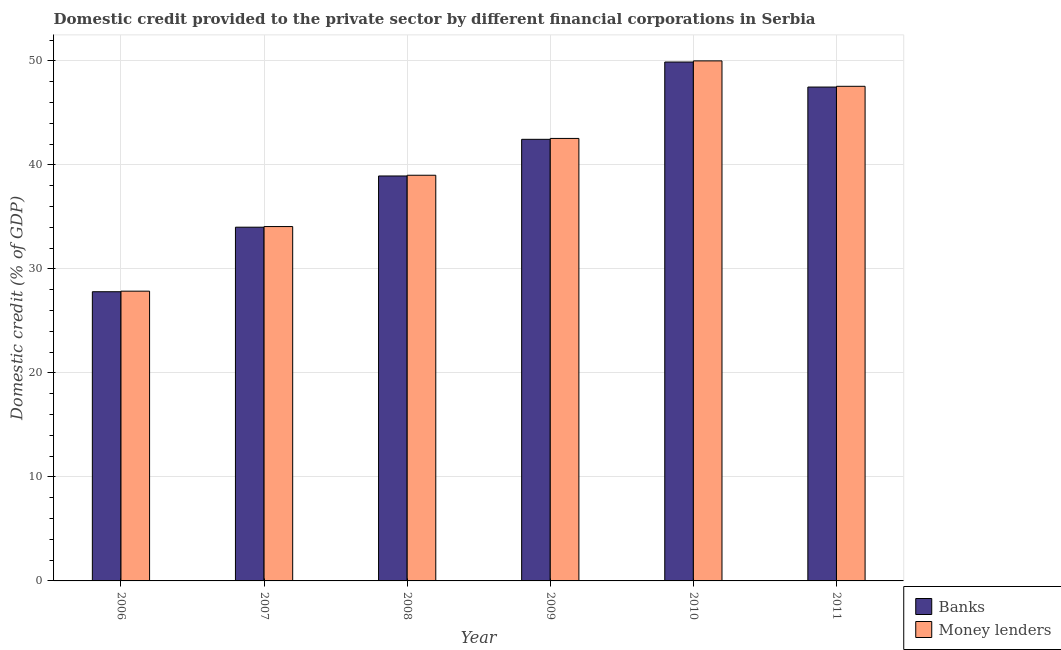How many different coloured bars are there?
Your answer should be very brief. 2. How many bars are there on the 3rd tick from the left?
Offer a very short reply. 2. How many bars are there on the 5th tick from the right?
Your answer should be compact. 2. What is the label of the 3rd group of bars from the left?
Make the answer very short. 2008. In how many cases, is the number of bars for a given year not equal to the number of legend labels?
Give a very brief answer. 0. What is the domestic credit provided by banks in 2007?
Offer a very short reply. 34.01. Across all years, what is the maximum domestic credit provided by banks?
Provide a succinct answer. 49.9. Across all years, what is the minimum domestic credit provided by banks?
Your answer should be compact. 27.81. In which year was the domestic credit provided by money lenders maximum?
Provide a short and direct response. 2010. In which year was the domestic credit provided by banks minimum?
Provide a succinct answer. 2006. What is the total domestic credit provided by money lenders in the graph?
Give a very brief answer. 241.07. What is the difference between the domestic credit provided by money lenders in 2006 and that in 2009?
Your answer should be compact. -14.69. What is the difference between the domestic credit provided by banks in 2008 and the domestic credit provided by money lenders in 2010?
Your answer should be compact. -10.96. What is the average domestic credit provided by banks per year?
Your response must be concise. 40.1. What is the ratio of the domestic credit provided by banks in 2006 to that in 2010?
Provide a short and direct response. 0.56. Is the difference between the domestic credit provided by banks in 2009 and 2011 greater than the difference between the domestic credit provided by money lenders in 2009 and 2011?
Offer a very short reply. No. What is the difference between the highest and the second highest domestic credit provided by banks?
Keep it short and to the point. 2.41. What is the difference between the highest and the lowest domestic credit provided by banks?
Your answer should be very brief. 22.09. In how many years, is the domestic credit provided by banks greater than the average domestic credit provided by banks taken over all years?
Provide a short and direct response. 3. Is the sum of the domestic credit provided by money lenders in 2007 and 2011 greater than the maximum domestic credit provided by banks across all years?
Give a very brief answer. Yes. What does the 2nd bar from the left in 2007 represents?
Offer a terse response. Money lenders. What does the 1st bar from the right in 2007 represents?
Your answer should be compact. Money lenders. How many bars are there?
Offer a very short reply. 12. Are the values on the major ticks of Y-axis written in scientific E-notation?
Keep it short and to the point. No. How are the legend labels stacked?
Give a very brief answer. Vertical. What is the title of the graph?
Provide a succinct answer. Domestic credit provided to the private sector by different financial corporations in Serbia. What is the label or title of the Y-axis?
Give a very brief answer. Domestic credit (% of GDP). What is the Domestic credit (% of GDP) in Banks in 2006?
Offer a terse response. 27.81. What is the Domestic credit (% of GDP) of Money lenders in 2006?
Your response must be concise. 27.86. What is the Domestic credit (% of GDP) in Banks in 2007?
Your answer should be compact. 34.01. What is the Domestic credit (% of GDP) of Money lenders in 2007?
Your answer should be very brief. 34.08. What is the Domestic credit (% of GDP) in Banks in 2008?
Make the answer very short. 38.94. What is the Domestic credit (% of GDP) of Money lenders in 2008?
Ensure brevity in your answer.  39.01. What is the Domestic credit (% of GDP) of Banks in 2009?
Provide a short and direct response. 42.46. What is the Domestic credit (% of GDP) in Money lenders in 2009?
Make the answer very short. 42.55. What is the Domestic credit (% of GDP) of Banks in 2010?
Give a very brief answer. 49.9. What is the Domestic credit (% of GDP) of Money lenders in 2010?
Your answer should be very brief. 50.01. What is the Domestic credit (% of GDP) in Banks in 2011?
Offer a very short reply. 47.49. What is the Domestic credit (% of GDP) in Money lenders in 2011?
Offer a very short reply. 47.56. Across all years, what is the maximum Domestic credit (% of GDP) in Banks?
Your answer should be compact. 49.9. Across all years, what is the maximum Domestic credit (% of GDP) of Money lenders?
Provide a short and direct response. 50.01. Across all years, what is the minimum Domestic credit (% of GDP) in Banks?
Your response must be concise. 27.81. Across all years, what is the minimum Domestic credit (% of GDP) of Money lenders?
Provide a succinct answer. 27.86. What is the total Domestic credit (% of GDP) in Banks in the graph?
Make the answer very short. 240.61. What is the total Domestic credit (% of GDP) in Money lenders in the graph?
Your answer should be very brief. 241.07. What is the difference between the Domestic credit (% of GDP) in Banks in 2006 and that in 2007?
Offer a terse response. -6.21. What is the difference between the Domestic credit (% of GDP) in Money lenders in 2006 and that in 2007?
Provide a succinct answer. -6.21. What is the difference between the Domestic credit (% of GDP) of Banks in 2006 and that in 2008?
Make the answer very short. -11.13. What is the difference between the Domestic credit (% of GDP) of Money lenders in 2006 and that in 2008?
Offer a very short reply. -11.15. What is the difference between the Domestic credit (% of GDP) of Banks in 2006 and that in 2009?
Offer a terse response. -14.66. What is the difference between the Domestic credit (% of GDP) in Money lenders in 2006 and that in 2009?
Offer a very short reply. -14.69. What is the difference between the Domestic credit (% of GDP) of Banks in 2006 and that in 2010?
Your answer should be very brief. -22.09. What is the difference between the Domestic credit (% of GDP) in Money lenders in 2006 and that in 2010?
Your answer should be compact. -22.14. What is the difference between the Domestic credit (% of GDP) in Banks in 2006 and that in 2011?
Your response must be concise. -19.68. What is the difference between the Domestic credit (% of GDP) in Money lenders in 2006 and that in 2011?
Your answer should be very brief. -19.7. What is the difference between the Domestic credit (% of GDP) in Banks in 2007 and that in 2008?
Keep it short and to the point. -4.93. What is the difference between the Domestic credit (% of GDP) in Money lenders in 2007 and that in 2008?
Your response must be concise. -4.93. What is the difference between the Domestic credit (% of GDP) in Banks in 2007 and that in 2009?
Your answer should be very brief. -8.45. What is the difference between the Domestic credit (% of GDP) of Money lenders in 2007 and that in 2009?
Provide a short and direct response. -8.47. What is the difference between the Domestic credit (% of GDP) of Banks in 2007 and that in 2010?
Give a very brief answer. -15.88. What is the difference between the Domestic credit (% of GDP) in Money lenders in 2007 and that in 2010?
Offer a very short reply. -15.93. What is the difference between the Domestic credit (% of GDP) of Banks in 2007 and that in 2011?
Your answer should be very brief. -13.48. What is the difference between the Domestic credit (% of GDP) in Money lenders in 2007 and that in 2011?
Make the answer very short. -13.49. What is the difference between the Domestic credit (% of GDP) in Banks in 2008 and that in 2009?
Provide a short and direct response. -3.52. What is the difference between the Domestic credit (% of GDP) in Money lenders in 2008 and that in 2009?
Provide a short and direct response. -3.54. What is the difference between the Domestic credit (% of GDP) in Banks in 2008 and that in 2010?
Provide a short and direct response. -10.96. What is the difference between the Domestic credit (% of GDP) in Money lenders in 2008 and that in 2010?
Make the answer very short. -11. What is the difference between the Domestic credit (% of GDP) in Banks in 2008 and that in 2011?
Ensure brevity in your answer.  -8.55. What is the difference between the Domestic credit (% of GDP) of Money lenders in 2008 and that in 2011?
Keep it short and to the point. -8.55. What is the difference between the Domestic credit (% of GDP) of Banks in 2009 and that in 2010?
Ensure brevity in your answer.  -7.43. What is the difference between the Domestic credit (% of GDP) of Money lenders in 2009 and that in 2010?
Offer a terse response. -7.46. What is the difference between the Domestic credit (% of GDP) in Banks in 2009 and that in 2011?
Your answer should be very brief. -5.03. What is the difference between the Domestic credit (% of GDP) of Money lenders in 2009 and that in 2011?
Your answer should be very brief. -5.01. What is the difference between the Domestic credit (% of GDP) of Banks in 2010 and that in 2011?
Give a very brief answer. 2.41. What is the difference between the Domestic credit (% of GDP) in Money lenders in 2010 and that in 2011?
Your answer should be compact. 2.44. What is the difference between the Domestic credit (% of GDP) in Banks in 2006 and the Domestic credit (% of GDP) in Money lenders in 2007?
Your answer should be very brief. -6.27. What is the difference between the Domestic credit (% of GDP) of Banks in 2006 and the Domestic credit (% of GDP) of Money lenders in 2008?
Offer a very short reply. -11.2. What is the difference between the Domestic credit (% of GDP) in Banks in 2006 and the Domestic credit (% of GDP) in Money lenders in 2009?
Offer a very short reply. -14.74. What is the difference between the Domestic credit (% of GDP) of Banks in 2006 and the Domestic credit (% of GDP) of Money lenders in 2010?
Give a very brief answer. -22.2. What is the difference between the Domestic credit (% of GDP) in Banks in 2006 and the Domestic credit (% of GDP) in Money lenders in 2011?
Offer a terse response. -19.75. What is the difference between the Domestic credit (% of GDP) of Banks in 2007 and the Domestic credit (% of GDP) of Money lenders in 2008?
Provide a succinct answer. -5. What is the difference between the Domestic credit (% of GDP) of Banks in 2007 and the Domestic credit (% of GDP) of Money lenders in 2009?
Give a very brief answer. -8.53. What is the difference between the Domestic credit (% of GDP) in Banks in 2007 and the Domestic credit (% of GDP) in Money lenders in 2010?
Give a very brief answer. -15.99. What is the difference between the Domestic credit (% of GDP) of Banks in 2007 and the Domestic credit (% of GDP) of Money lenders in 2011?
Your answer should be compact. -13.55. What is the difference between the Domestic credit (% of GDP) in Banks in 2008 and the Domestic credit (% of GDP) in Money lenders in 2009?
Your answer should be very brief. -3.61. What is the difference between the Domestic credit (% of GDP) in Banks in 2008 and the Domestic credit (% of GDP) in Money lenders in 2010?
Provide a short and direct response. -11.07. What is the difference between the Domestic credit (% of GDP) in Banks in 2008 and the Domestic credit (% of GDP) in Money lenders in 2011?
Provide a succinct answer. -8.62. What is the difference between the Domestic credit (% of GDP) in Banks in 2009 and the Domestic credit (% of GDP) in Money lenders in 2010?
Provide a succinct answer. -7.54. What is the difference between the Domestic credit (% of GDP) of Banks in 2009 and the Domestic credit (% of GDP) of Money lenders in 2011?
Your response must be concise. -5.1. What is the difference between the Domestic credit (% of GDP) of Banks in 2010 and the Domestic credit (% of GDP) of Money lenders in 2011?
Your answer should be compact. 2.33. What is the average Domestic credit (% of GDP) of Banks per year?
Provide a succinct answer. 40.1. What is the average Domestic credit (% of GDP) of Money lenders per year?
Offer a terse response. 40.18. In the year 2006, what is the difference between the Domestic credit (% of GDP) of Banks and Domestic credit (% of GDP) of Money lenders?
Offer a very short reply. -0.05. In the year 2007, what is the difference between the Domestic credit (% of GDP) of Banks and Domestic credit (% of GDP) of Money lenders?
Make the answer very short. -0.06. In the year 2008, what is the difference between the Domestic credit (% of GDP) of Banks and Domestic credit (% of GDP) of Money lenders?
Your answer should be compact. -0.07. In the year 2009, what is the difference between the Domestic credit (% of GDP) in Banks and Domestic credit (% of GDP) in Money lenders?
Give a very brief answer. -0.09. In the year 2010, what is the difference between the Domestic credit (% of GDP) of Banks and Domestic credit (% of GDP) of Money lenders?
Your answer should be compact. -0.11. In the year 2011, what is the difference between the Domestic credit (% of GDP) of Banks and Domestic credit (% of GDP) of Money lenders?
Your answer should be compact. -0.07. What is the ratio of the Domestic credit (% of GDP) of Banks in 2006 to that in 2007?
Your answer should be very brief. 0.82. What is the ratio of the Domestic credit (% of GDP) in Money lenders in 2006 to that in 2007?
Provide a succinct answer. 0.82. What is the ratio of the Domestic credit (% of GDP) in Banks in 2006 to that in 2008?
Offer a very short reply. 0.71. What is the ratio of the Domestic credit (% of GDP) of Money lenders in 2006 to that in 2008?
Provide a short and direct response. 0.71. What is the ratio of the Domestic credit (% of GDP) of Banks in 2006 to that in 2009?
Your response must be concise. 0.65. What is the ratio of the Domestic credit (% of GDP) in Money lenders in 2006 to that in 2009?
Your response must be concise. 0.65. What is the ratio of the Domestic credit (% of GDP) of Banks in 2006 to that in 2010?
Give a very brief answer. 0.56. What is the ratio of the Domestic credit (% of GDP) of Money lenders in 2006 to that in 2010?
Your response must be concise. 0.56. What is the ratio of the Domestic credit (% of GDP) of Banks in 2006 to that in 2011?
Your answer should be very brief. 0.59. What is the ratio of the Domestic credit (% of GDP) of Money lenders in 2006 to that in 2011?
Provide a succinct answer. 0.59. What is the ratio of the Domestic credit (% of GDP) in Banks in 2007 to that in 2008?
Provide a short and direct response. 0.87. What is the ratio of the Domestic credit (% of GDP) in Money lenders in 2007 to that in 2008?
Ensure brevity in your answer.  0.87. What is the ratio of the Domestic credit (% of GDP) in Banks in 2007 to that in 2009?
Give a very brief answer. 0.8. What is the ratio of the Domestic credit (% of GDP) of Money lenders in 2007 to that in 2009?
Your answer should be compact. 0.8. What is the ratio of the Domestic credit (% of GDP) of Banks in 2007 to that in 2010?
Ensure brevity in your answer.  0.68. What is the ratio of the Domestic credit (% of GDP) of Money lenders in 2007 to that in 2010?
Provide a succinct answer. 0.68. What is the ratio of the Domestic credit (% of GDP) in Banks in 2007 to that in 2011?
Provide a short and direct response. 0.72. What is the ratio of the Domestic credit (% of GDP) of Money lenders in 2007 to that in 2011?
Provide a succinct answer. 0.72. What is the ratio of the Domestic credit (% of GDP) in Banks in 2008 to that in 2009?
Provide a short and direct response. 0.92. What is the ratio of the Domestic credit (% of GDP) in Money lenders in 2008 to that in 2009?
Provide a short and direct response. 0.92. What is the ratio of the Domestic credit (% of GDP) of Banks in 2008 to that in 2010?
Provide a succinct answer. 0.78. What is the ratio of the Domestic credit (% of GDP) in Money lenders in 2008 to that in 2010?
Provide a succinct answer. 0.78. What is the ratio of the Domestic credit (% of GDP) of Banks in 2008 to that in 2011?
Give a very brief answer. 0.82. What is the ratio of the Domestic credit (% of GDP) of Money lenders in 2008 to that in 2011?
Provide a short and direct response. 0.82. What is the ratio of the Domestic credit (% of GDP) of Banks in 2009 to that in 2010?
Provide a short and direct response. 0.85. What is the ratio of the Domestic credit (% of GDP) in Money lenders in 2009 to that in 2010?
Give a very brief answer. 0.85. What is the ratio of the Domestic credit (% of GDP) of Banks in 2009 to that in 2011?
Ensure brevity in your answer.  0.89. What is the ratio of the Domestic credit (% of GDP) of Money lenders in 2009 to that in 2011?
Give a very brief answer. 0.89. What is the ratio of the Domestic credit (% of GDP) of Banks in 2010 to that in 2011?
Provide a short and direct response. 1.05. What is the ratio of the Domestic credit (% of GDP) of Money lenders in 2010 to that in 2011?
Provide a succinct answer. 1.05. What is the difference between the highest and the second highest Domestic credit (% of GDP) in Banks?
Keep it short and to the point. 2.41. What is the difference between the highest and the second highest Domestic credit (% of GDP) of Money lenders?
Provide a succinct answer. 2.44. What is the difference between the highest and the lowest Domestic credit (% of GDP) of Banks?
Give a very brief answer. 22.09. What is the difference between the highest and the lowest Domestic credit (% of GDP) of Money lenders?
Give a very brief answer. 22.14. 